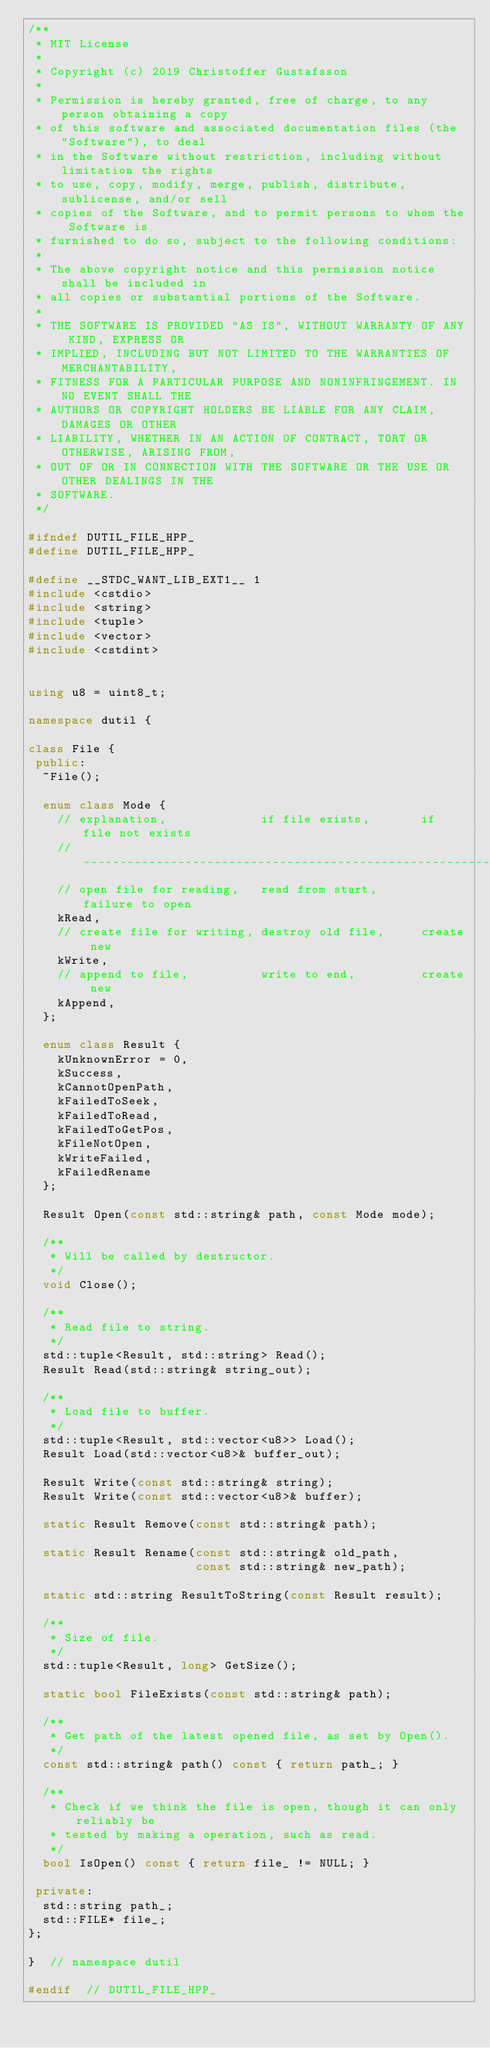<code> <loc_0><loc_0><loc_500><loc_500><_C++_>/**
 * MIT License
 *
 * Copyright (c) 2019 Christoffer Gustafsson
 *
 * Permission is hereby granted, free of charge, to any person obtaining a copy
 * of this software and associated documentation files (the "Software"), to deal
 * in the Software without restriction, including without limitation the rights
 * to use, copy, modify, merge, publish, distribute, sublicense, and/or sell
 * copies of the Software, and to permit persons to whom the Software is
 * furnished to do so, subject to the following conditions:
 *
 * The above copyright notice and this permission notice shall be included in
 * all copies or substantial portions of the Software.
 *
 * THE SOFTWARE IS PROVIDED "AS IS", WITHOUT WARRANTY OF ANY KIND, EXPRESS OR
 * IMPLIED, INCLUDING BUT NOT LIMITED TO THE WARRANTIES OF MERCHANTABILITY,
 * FITNESS FOR A PARTICULAR PURPOSE AND NONINFRINGEMENT. IN NO EVENT SHALL THE
 * AUTHORS OR COPYRIGHT HOLDERS BE LIABLE FOR ANY CLAIM, DAMAGES OR OTHER
 * LIABILITY, WHETHER IN AN ACTION OF CONTRACT, TORT OR OTHERWISE, ARISING FROM,
 * OUT OF OR IN CONNECTION WITH THE SOFTWARE OR THE USE OR OTHER DEALINGS IN THE
 * SOFTWARE.
 */

#ifndef DUTIL_FILE_HPP_
#define DUTIL_FILE_HPP_

#define __STDC_WANT_LIB_EXT1__ 1
#include <cstdio>
#include <string>
#include <tuple>
#include <vector>
#include <cstdint>


using u8 = uint8_t;

namespace dutil {

class File {
 public:
  ~File();

  enum class Mode {
    // explanation,             if file exists,       if file not exists
    //-----------------------------------------------------------------
    // open file for reading,   read from start,      failure to open
    kRead,
    // create file for writing, destroy old file,     create new
    kWrite,
    // append to file,          write to end,         create new
    kAppend,
  };

  enum class Result {
    kUnknownError = 0,
    kSuccess,
    kCannotOpenPath,
    kFailedToSeek,
    kFailedToRead,
    kFailedToGetPos,
    kFileNotOpen,
    kWriteFailed,
    kFailedRename
  };

  Result Open(const std::string& path, const Mode mode);

  /**
   * Will be called by destructor.
   */
  void Close();

  /**
   * Read file to string.
   */
  std::tuple<Result, std::string> Read();
  Result Read(std::string& string_out);

  /**
   * Load file to buffer.
   */
  std::tuple<Result, std::vector<u8>> Load();
  Result Load(std::vector<u8>& buffer_out);

  Result Write(const std::string& string);
  Result Write(const std::vector<u8>& buffer);

  static Result Remove(const std::string& path);

  static Result Rename(const std::string& old_path,
                       const std::string& new_path);

  static std::string ResultToString(const Result result);

  /**
   * Size of file.
   */
  std::tuple<Result, long> GetSize();

  static bool FileExists(const std::string& path);

  /**
   * Get path of the latest opened file, as set by Open().
   */
  const std::string& path() const { return path_; }

  /**
   * Check if we think the file is open, though it can only reliably be
   * tested by making a operation, such as read.
   */
  bool IsOpen() const { return file_ != NULL; }

 private:
  std::string path_;
  std::FILE* file_;
};

}  // namespace dutil

#endif  // DUTIL_FILE_HPP_
</code> 